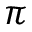<formula> <loc_0><loc_0><loc_500><loc_500>\pi</formula> 